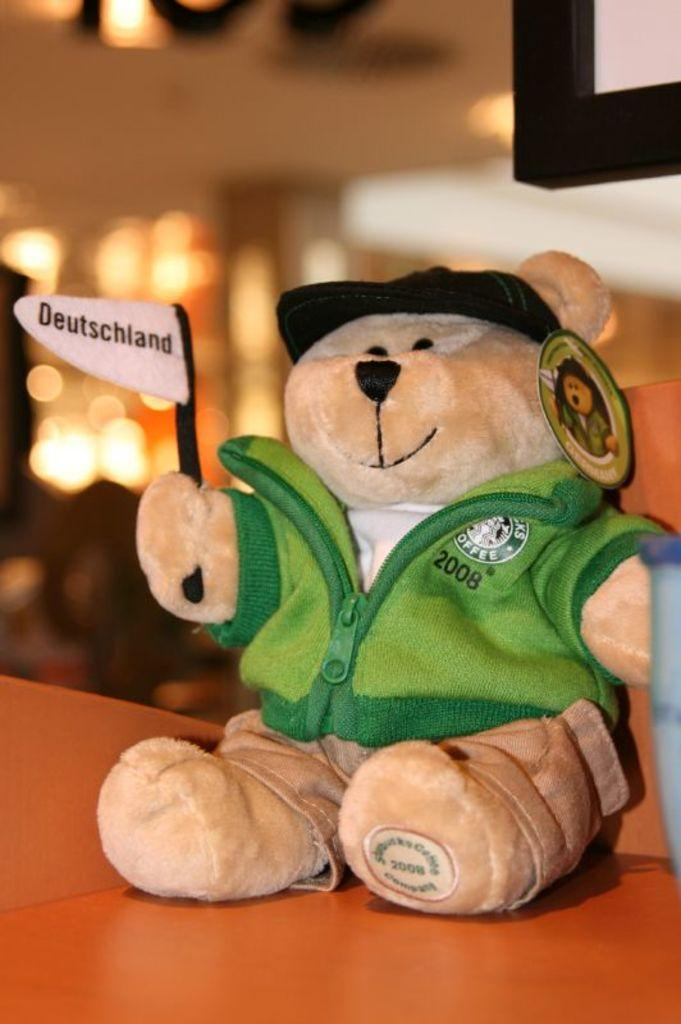What is the main subject of the image? There is a teddy bear in the image. Where is the teddy bear bear located? The teddy bear is on a table. What type of underwear is the teddy bear wearing in the image? There is no underwear present in the image, as the subject is a teddy bear, which is an inanimate object and does not wear clothing. 